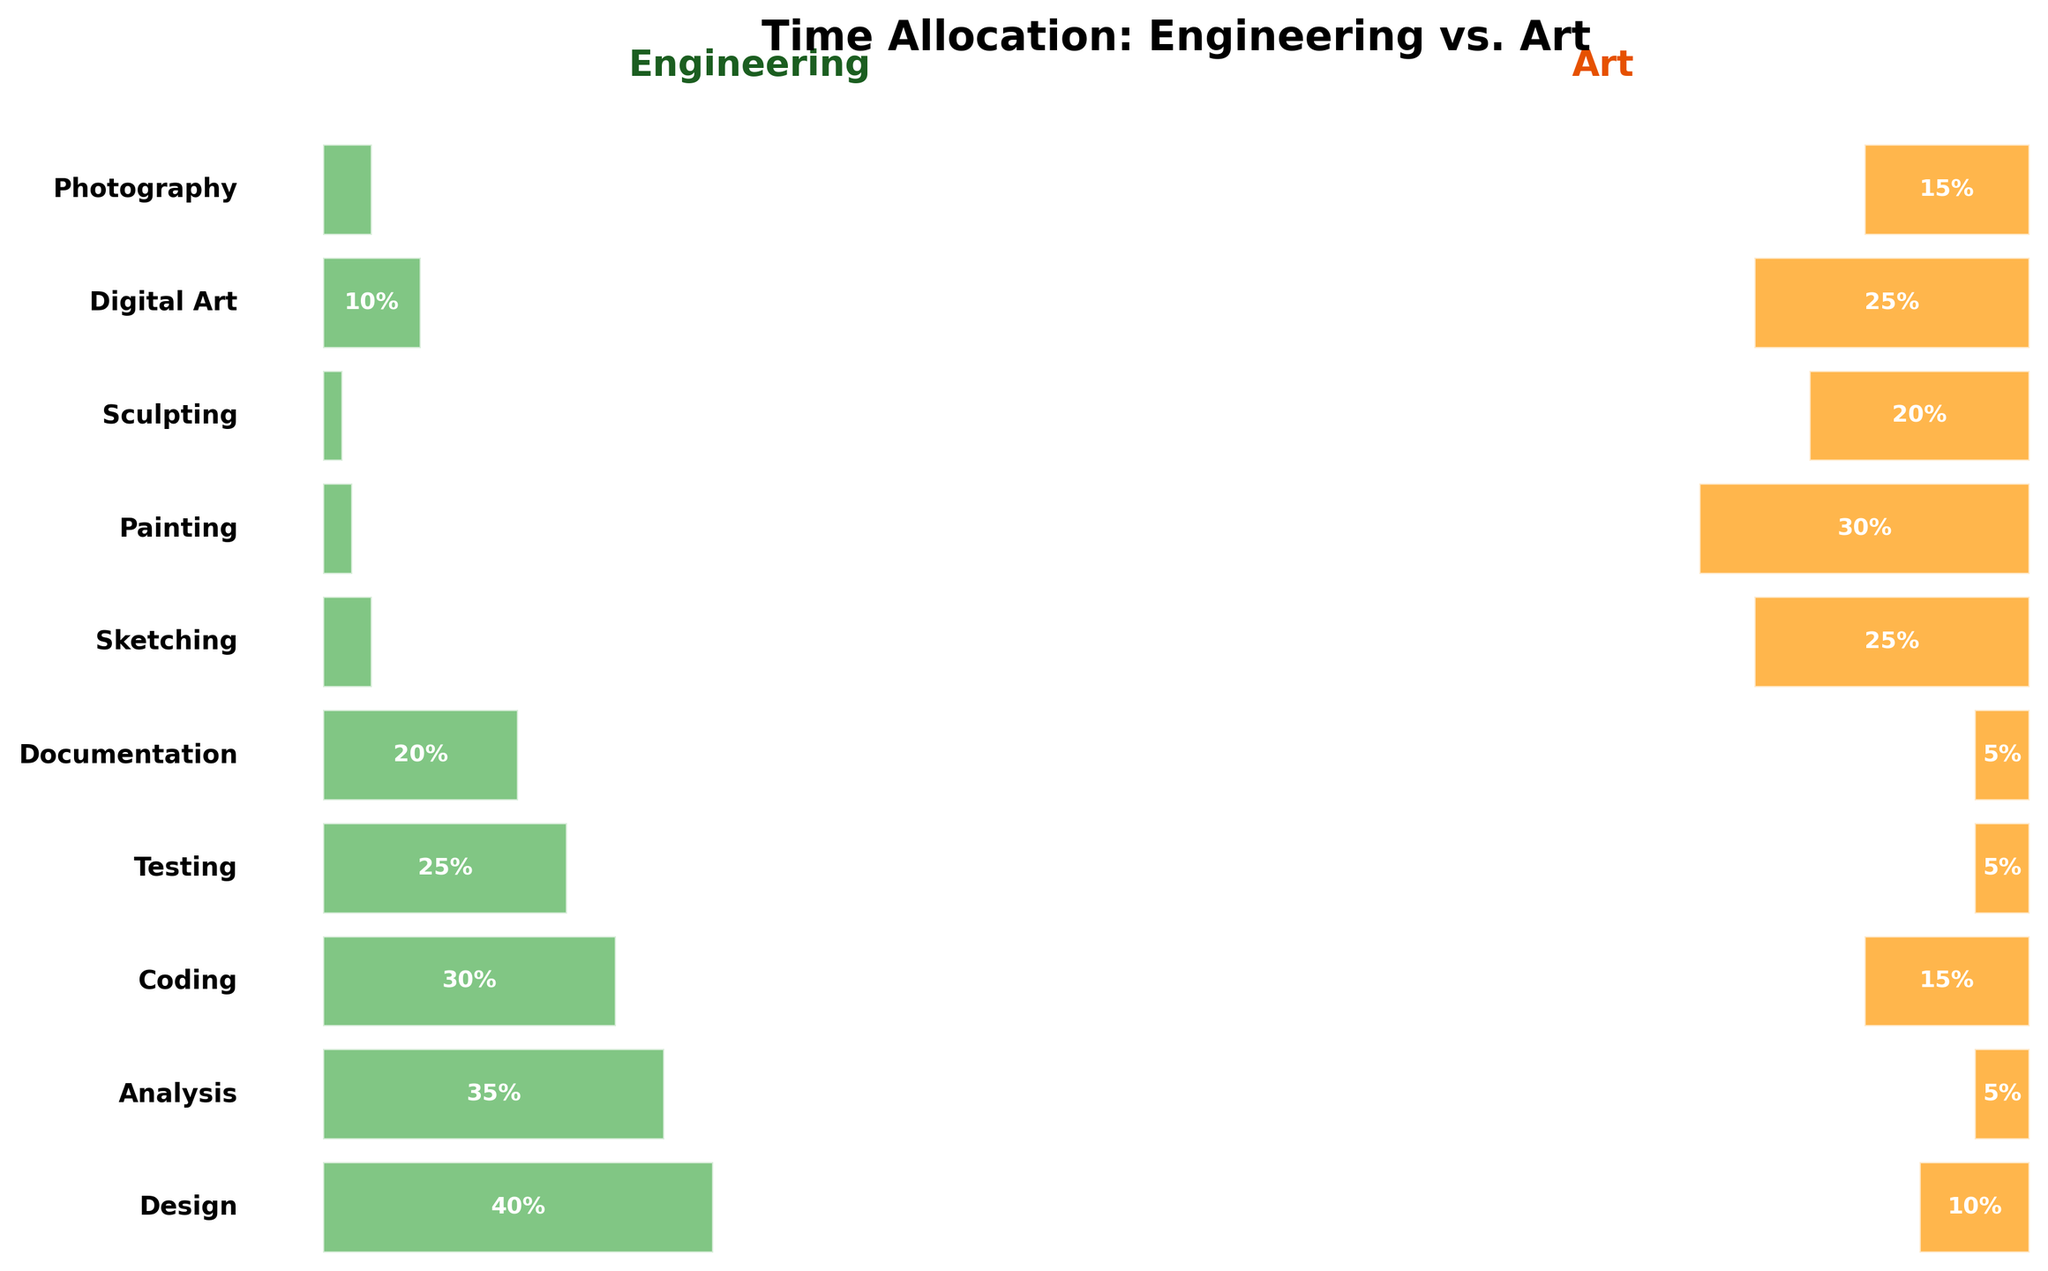What's the title of the plot? At the top of the figure, there is a clear title stating "Time Allocation: Engineering vs. Art", making it easy to identify what the plot is about.
Answer: Time Allocation: Engineering vs. Art What are the colors used to represent Engineering and Art? In the plot, rectangles on the left are shaded in green, representing Engineering, and rectangles on the right are shaded in orange, representing Art.
Answer: Green for Engineering, Orange for Art Which task has the highest time allocation in the Engineering category? By looking at the lengths of the green bars on the left side, it is evident that "Design" has the longest bar, indicating the highest time allocation in the Engineering category.
Answer: Design How many tasks devote at least 20% of time to Art? Observing the lengths of the orange bars on the right, "Sketching", "Painting", "Sculpting", and "Digital Art" have substantial lengths indicating they are more than 20%. Count these tasks.
Answer: 4 Which category has the least time dedicated to tasks? By comparing the total lengths of the green and orange bars, the orange bars representing "Art" generally occupy more area visually, meaning the "Engineering" side has the least time dedicated.
Answer: Engineering How much total time allocation is given to Testing across both categories? The plot shows Testing with 25% in Engineering and 5% in Art. Add these percentages together: 25% + 5%.
Answer: 30% Which task has an equal time allocation in both categories? By looking at the matching lengths of the bars, "Photography" has equal allocation with 5% for Engineering and 15% for Art.
Answer: Photography How does the time allocated to Painting compare between the two categories? The green bar for Painting is much shorter (3%) compared to the orange bar (30%). Therefore, more time is dedicated to Painting in the Art category.
Answer: More time in Art What is the combined percentage of time devoted to Documentation and Coding in Art? The plot shows Documentation at 5% and Coding at 15% for Art. Add these two values together: 5% + 15%.
Answer: 20% Which task shows the highest disparity between Engineering and Art time allocation? Comparing the lengths of the bars, "Painting" has the highest disparity, with a large difference between 3% in Engineering and 30% in Art.
Answer: Painting 